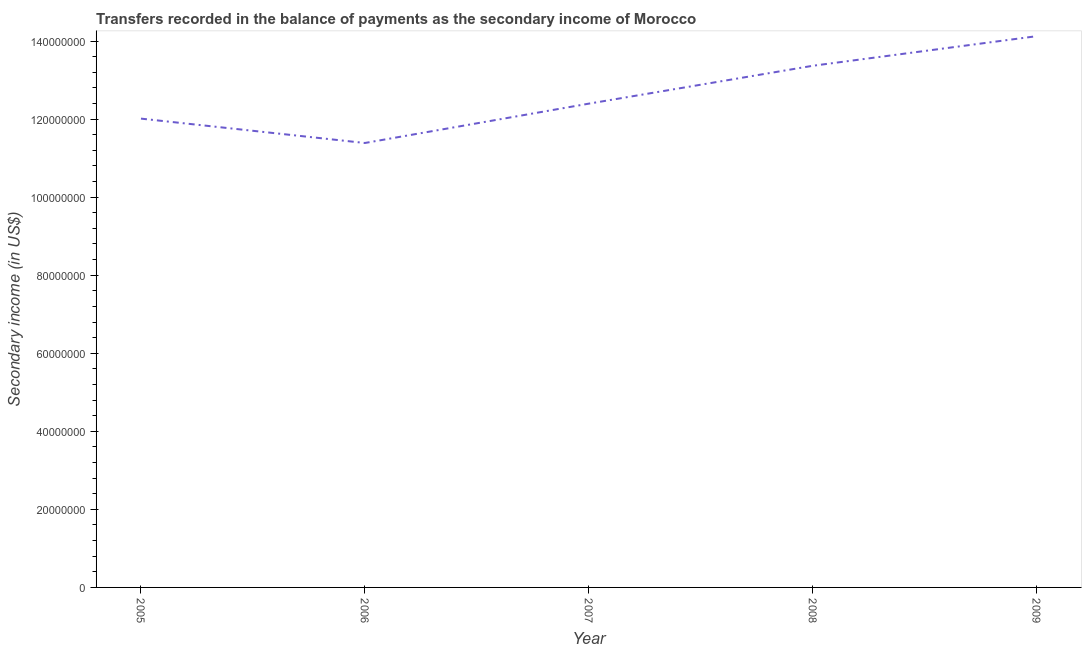What is the amount of secondary income in 2007?
Your answer should be very brief. 1.24e+08. Across all years, what is the maximum amount of secondary income?
Make the answer very short. 1.41e+08. Across all years, what is the minimum amount of secondary income?
Provide a succinct answer. 1.14e+08. In which year was the amount of secondary income maximum?
Offer a terse response. 2009. What is the sum of the amount of secondary income?
Your answer should be very brief. 6.33e+08. What is the difference between the amount of secondary income in 2007 and 2008?
Offer a very short reply. -9.70e+06. What is the average amount of secondary income per year?
Offer a very short reply. 1.27e+08. What is the median amount of secondary income?
Offer a very short reply. 1.24e+08. In how many years, is the amount of secondary income greater than 44000000 US$?
Provide a short and direct response. 5. What is the ratio of the amount of secondary income in 2008 to that in 2009?
Offer a very short reply. 0.95. What is the difference between the highest and the second highest amount of secondary income?
Provide a short and direct response. 7.59e+06. What is the difference between the highest and the lowest amount of secondary income?
Your answer should be very brief. 2.74e+07. Does the amount of secondary income monotonically increase over the years?
Keep it short and to the point. No. How many lines are there?
Your answer should be very brief. 1. What is the difference between two consecutive major ticks on the Y-axis?
Offer a very short reply. 2.00e+07. Are the values on the major ticks of Y-axis written in scientific E-notation?
Offer a terse response. No. Does the graph contain any zero values?
Make the answer very short. No. What is the title of the graph?
Make the answer very short. Transfers recorded in the balance of payments as the secondary income of Morocco. What is the label or title of the X-axis?
Your answer should be compact. Year. What is the label or title of the Y-axis?
Make the answer very short. Secondary income (in US$). What is the Secondary income (in US$) in 2005?
Offer a very short reply. 1.20e+08. What is the Secondary income (in US$) in 2006?
Offer a terse response. 1.14e+08. What is the Secondary income (in US$) of 2007?
Ensure brevity in your answer.  1.24e+08. What is the Secondary income (in US$) of 2008?
Make the answer very short. 1.34e+08. What is the Secondary income (in US$) of 2009?
Give a very brief answer. 1.41e+08. What is the difference between the Secondary income (in US$) in 2005 and 2006?
Give a very brief answer. 6.24e+06. What is the difference between the Secondary income (in US$) in 2005 and 2007?
Keep it short and to the point. -3.84e+06. What is the difference between the Secondary income (in US$) in 2005 and 2008?
Keep it short and to the point. -1.35e+07. What is the difference between the Secondary income (in US$) in 2005 and 2009?
Offer a very short reply. -2.11e+07. What is the difference between the Secondary income (in US$) in 2006 and 2007?
Ensure brevity in your answer.  -1.01e+07. What is the difference between the Secondary income (in US$) in 2006 and 2008?
Keep it short and to the point. -1.98e+07. What is the difference between the Secondary income (in US$) in 2006 and 2009?
Your answer should be very brief. -2.74e+07. What is the difference between the Secondary income (in US$) in 2007 and 2008?
Keep it short and to the point. -9.70e+06. What is the difference between the Secondary income (in US$) in 2007 and 2009?
Ensure brevity in your answer.  -1.73e+07. What is the difference between the Secondary income (in US$) in 2008 and 2009?
Ensure brevity in your answer.  -7.59e+06. What is the ratio of the Secondary income (in US$) in 2005 to that in 2006?
Ensure brevity in your answer.  1.05. What is the ratio of the Secondary income (in US$) in 2005 to that in 2008?
Offer a terse response. 0.9. What is the ratio of the Secondary income (in US$) in 2006 to that in 2007?
Give a very brief answer. 0.92. What is the ratio of the Secondary income (in US$) in 2006 to that in 2008?
Offer a terse response. 0.85. What is the ratio of the Secondary income (in US$) in 2006 to that in 2009?
Your response must be concise. 0.81. What is the ratio of the Secondary income (in US$) in 2007 to that in 2008?
Give a very brief answer. 0.93. What is the ratio of the Secondary income (in US$) in 2007 to that in 2009?
Provide a succinct answer. 0.88. What is the ratio of the Secondary income (in US$) in 2008 to that in 2009?
Ensure brevity in your answer.  0.95. 